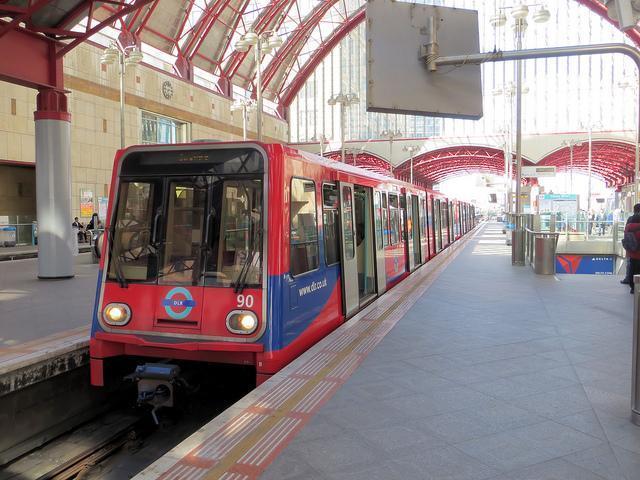How many trains are there?
Give a very brief answer. 1. 